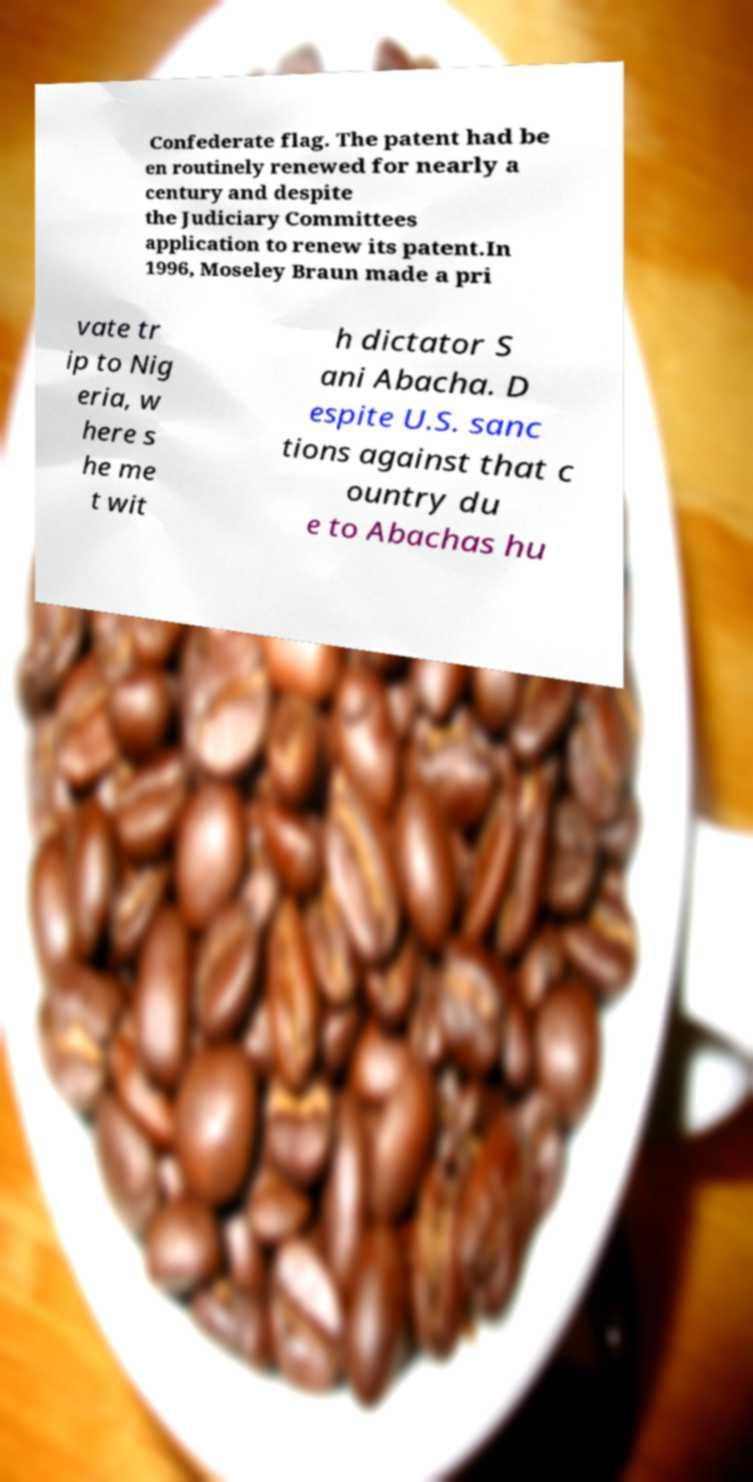Please read and relay the text visible in this image. What does it say? Confederate flag. The patent had be en routinely renewed for nearly a century and despite the Judiciary Committees application to renew its patent.In 1996, Moseley Braun made a pri vate tr ip to Nig eria, w here s he me t wit h dictator S ani Abacha. D espite U.S. sanc tions against that c ountry du e to Abachas hu 